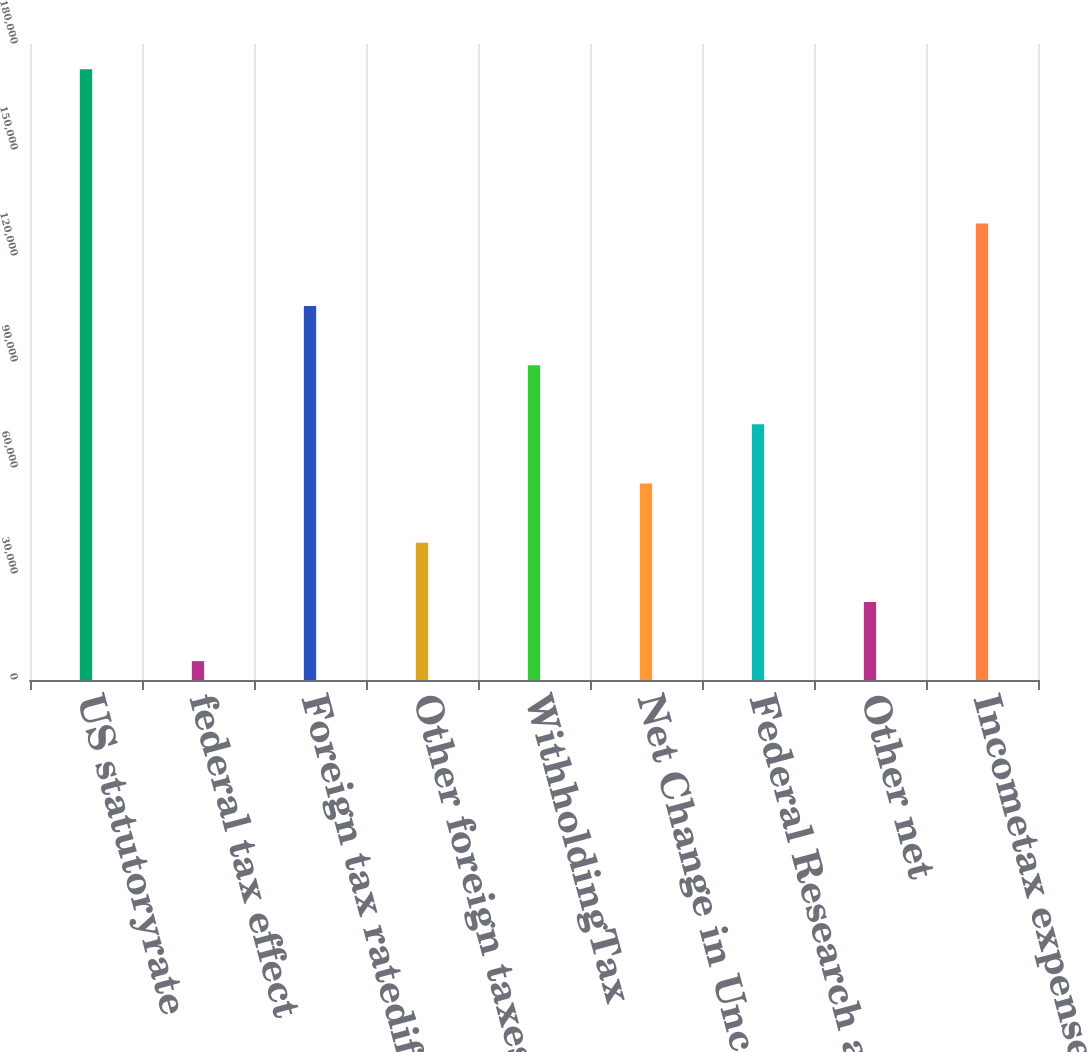Convert chart. <chart><loc_0><loc_0><loc_500><loc_500><bar_chart><fcel>US statutoryrate<fcel>federal tax effect<fcel>Foreign tax ratedifferential<fcel>Other foreign taxes less<fcel>WithholdingTax<fcel>Net Change in Uncertain Tax<fcel>Federal Research and<fcel>Other net<fcel>Incometax expense (benefit)<nl><fcel>172882<fcel>5339<fcel>105865<fcel>38847.6<fcel>89110.5<fcel>55601.9<fcel>72356.2<fcel>22093.3<fcel>129167<nl></chart> 